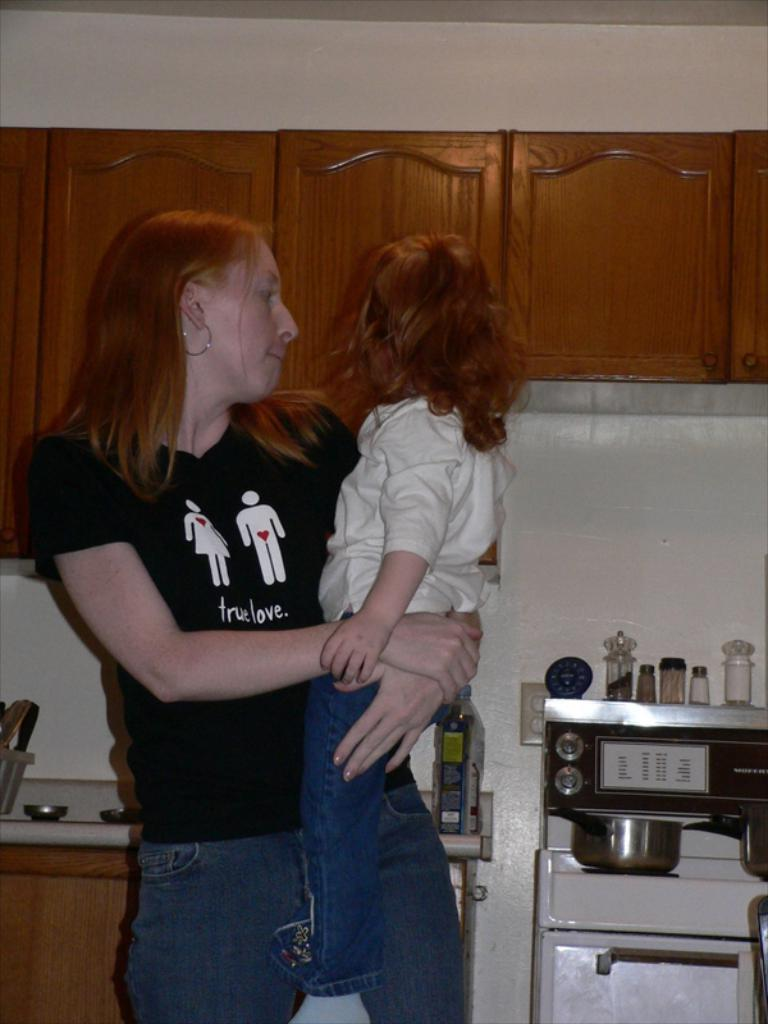<image>
Relay a brief, clear account of the picture shown. the word love is on the shirt of the lady 